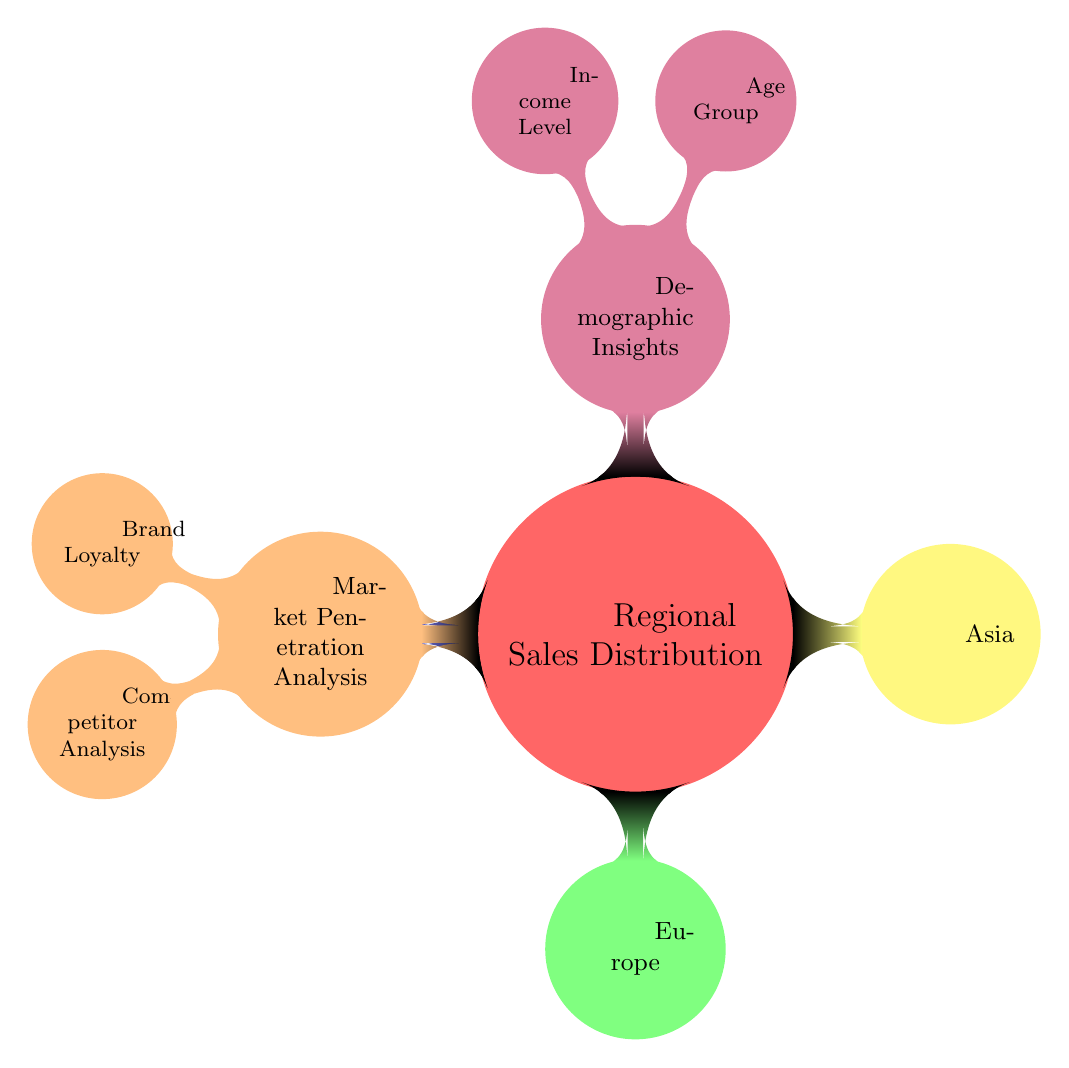What are the four main categories in the diagram? The diagram has four main categories which are Regional Sales Distribution, Demographic Insights, Market Penetration Analysis, and the specific regions under Regional Sales Distribution.
Answer: Regional Sales Distribution, Demographic Insights, Market Penetration Analysis Which region is represented with the color green? In the diagram, the green color is designated for Europe as part of the Regional Sales Distribution.
Answer: Europe How many child categories are under the Demographic Insights node? The Demographic Insights node has two child categories: Age Group and Income Level. Counting these gives us a total of two.
Answer: 2 Which node is a child of Market Penetration Analysis? The Market Penetration Analysis node has two child nodes: Brand Loyalty and Competitor Analysis. Both of these are relevant for understanding market penetration.
Answer: Brand Loyalty and Competitor Analysis What color is used for the North America node? The North America node in the diagram is represented by a blue color.
Answer: Blue Which demographic aspect includes Age Group? Age Group is categorized as one of the child nodes under Demographic Insights, indicating that it is a demographic aspect related to regional sales.
Answer: Demographic Insights What is the sibling angle between the regions? The sibling angle between the regions in the diagram is set at 90 degrees, resulting in a circular arrangement of the regions around the main topic.
Answer: 90 degrees How many total regions are listed in the Regional Sales Distribution? Under the Regional Sales Distribution node, there are three specific regions mentioned: North America, Europe, and Asia. Counting these gives us a total of three regions.
Answer: 3 